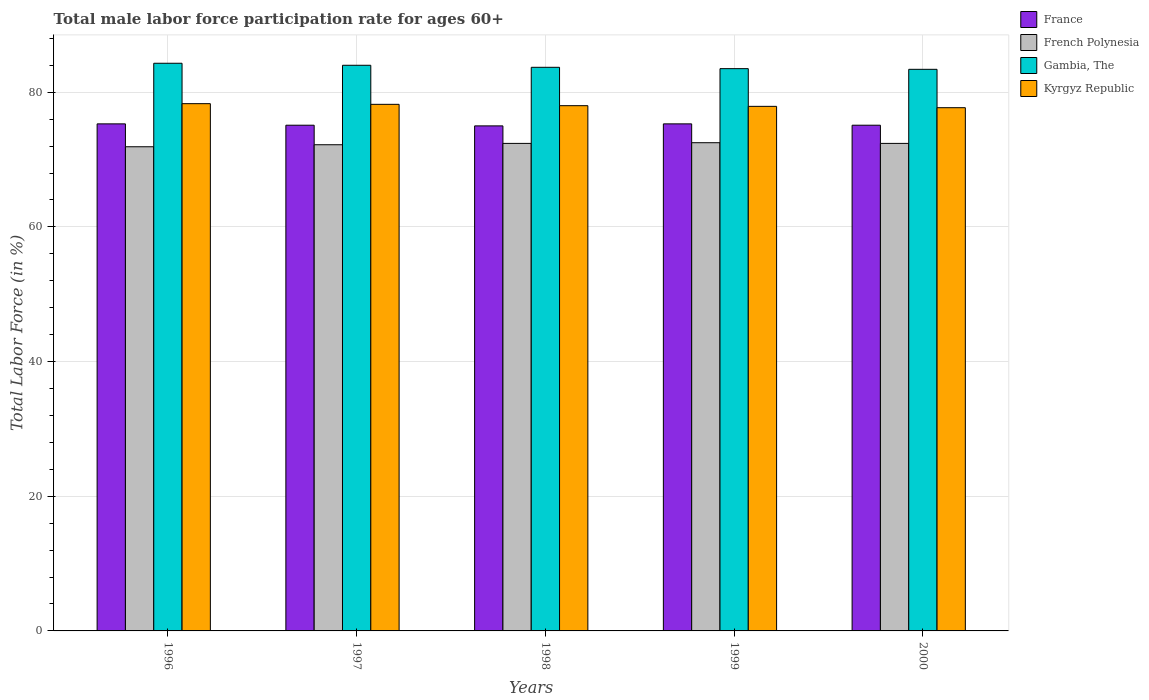How many different coloured bars are there?
Make the answer very short. 4. Are the number of bars on each tick of the X-axis equal?
Make the answer very short. Yes. Across all years, what is the maximum male labor force participation rate in Kyrgyz Republic?
Give a very brief answer. 78.3. In which year was the male labor force participation rate in French Polynesia maximum?
Provide a succinct answer. 1999. In which year was the male labor force participation rate in Kyrgyz Republic minimum?
Offer a very short reply. 2000. What is the total male labor force participation rate in French Polynesia in the graph?
Your response must be concise. 361.4. What is the difference between the male labor force participation rate in Gambia, The in 1997 and that in 2000?
Provide a short and direct response. 0.6. What is the difference between the male labor force participation rate in French Polynesia in 2000 and the male labor force participation rate in Gambia, The in 1997?
Give a very brief answer. -11.6. What is the average male labor force participation rate in French Polynesia per year?
Provide a succinct answer. 72.28. In the year 1998, what is the difference between the male labor force participation rate in Gambia, The and male labor force participation rate in Kyrgyz Republic?
Your response must be concise. 5.7. What is the ratio of the male labor force participation rate in France in 1997 to that in 1999?
Ensure brevity in your answer.  1. Is the difference between the male labor force participation rate in Gambia, The in 1997 and 1999 greater than the difference between the male labor force participation rate in Kyrgyz Republic in 1997 and 1999?
Provide a short and direct response. Yes. What is the difference between the highest and the second highest male labor force participation rate in France?
Provide a short and direct response. 0. What is the difference between the highest and the lowest male labor force participation rate in Kyrgyz Republic?
Offer a terse response. 0.6. Is the sum of the male labor force participation rate in Kyrgyz Republic in 1998 and 2000 greater than the maximum male labor force participation rate in French Polynesia across all years?
Your answer should be compact. Yes. Is it the case that in every year, the sum of the male labor force participation rate in French Polynesia and male labor force participation rate in Kyrgyz Republic is greater than the sum of male labor force participation rate in France and male labor force participation rate in Gambia, The?
Provide a succinct answer. No. What does the 3rd bar from the left in 1998 represents?
Your answer should be compact. Gambia, The. What does the 2nd bar from the right in 1997 represents?
Keep it short and to the point. Gambia, The. How many bars are there?
Your answer should be very brief. 20. Are all the bars in the graph horizontal?
Offer a terse response. No. What is the difference between two consecutive major ticks on the Y-axis?
Your response must be concise. 20. How are the legend labels stacked?
Provide a short and direct response. Vertical. What is the title of the graph?
Make the answer very short. Total male labor force participation rate for ages 60+. Does "Bahrain" appear as one of the legend labels in the graph?
Keep it short and to the point. No. What is the label or title of the X-axis?
Keep it short and to the point. Years. What is the Total Labor Force (in %) in France in 1996?
Offer a very short reply. 75.3. What is the Total Labor Force (in %) of French Polynesia in 1996?
Offer a very short reply. 71.9. What is the Total Labor Force (in %) of Gambia, The in 1996?
Your answer should be very brief. 84.3. What is the Total Labor Force (in %) in Kyrgyz Republic in 1996?
Offer a terse response. 78.3. What is the Total Labor Force (in %) of France in 1997?
Provide a succinct answer. 75.1. What is the Total Labor Force (in %) of French Polynesia in 1997?
Provide a succinct answer. 72.2. What is the Total Labor Force (in %) in Kyrgyz Republic in 1997?
Your answer should be compact. 78.2. What is the Total Labor Force (in %) in France in 1998?
Keep it short and to the point. 75. What is the Total Labor Force (in %) of French Polynesia in 1998?
Your response must be concise. 72.4. What is the Total Labor Force (in %) in Gambia, The in 1998?
Your answer should be compact. 83.7. What is the Total Labor Force (in %) in Kyrgyz Republic in 1998?
Provide a short and direct response. 78. What is the Total Labor Force (in %) of France in 1999?
Provide a short and direct response. 75.3. What is the Total Labor Force (in %) of French Polynesia in 1999?
Provide a short and direct response. 72.5. What is the Total Labor Force (in %) of Gambia, The in 1999?
Give a very brief answer. 83.5. What is the Total Labor Force (in %) in Kyrgyz Republic in 1999?
Offer a very short reply. 77.9. What is the Total Labor Force (in %) of France in 2000?
Provide a short and direct response. 75.1. What is the Total Labor Force (in %) of French Polynesia in 2000?
Ensure brevity in your answer.  72.4. What is the Total Labor Force (in %) in Gambia, The in 2000?
Offer a very short reply. 83.4. What is the Total Labor Force (in %) in Kyrgyz Republic in 2000?
Provide a short and direct response. 77.7. Across all years, what is the maximum Total Labor Force (in %) in France?
Keep it short and to the point. 75.3. Across all years, what is the maximum Total Labor Force (in %) in French Polynesia?
Your answer should be compact. 72.5. Across all years, what is the maximum Total Labor Force (in %) of Gambia, The?
Provide a succinct answer. 84.3. Across all years, what is the maximum Total Labor Force (in %) of Kyrgyz Republic?
Your answer should be compact. 78.3. Across all years, what is the minimum Total Labor Force (in %) in France?
Give a very brief answer. 75. Across all years, what is the minimum Total Labor Force (in %) of French Polynesia?
Offer a very short reply. 71.9. Across all years, what is the minimum Total Labor Force (in %) in Gambia, The?
Your answer should be very brief. 83.4. Across all years, what is the minimum Total Labor Force (in %) of Kyrgyz Republic?
Offer a terse response. 77.7. What is the total Total Labor Force (in %) in France in the graph?
Make the answer very short. 375.8. What is the total Total Labor Force (in %) in French Polynesia in the graph?
Your answer should be very brief. 361.4. What is the total Total Labor Force (in %) in Gambia, The in the graph?
Provide a succinct answer. 418.9. What is the total Total Labor Force (in %) in Kyrgyz Republic in the graph?
Provide a succinct answer. 390.1. What is the difference between the Total Labor Force (in %) in France in 1996 and that in 1997?
Offer a terse response. 0.2. What is the difference between the Total Labor Force (in %) in French Polynesia in 1996 and that in 1998?
Your answer should be compact. -0.5. What is the difference between the Total Labor Force (in %) in French Polynesia in 1996 and that in 1999?
Keep it short and to the point. -0.6. What is the difference between the Total Labor Force (in %) in Gambia, The in 1996 and that in 1999?
Offer a terse response. 0.8. What is the difference between the Total Labor Force (in %) of Kyrgyz Republic in 1996 and that in 1999?
Your response must be concise. 0.4. What is the difference between the Total Labor Force (in %) in French Polynesia in 1997 and that in 1999?
Offer a terse response. -0.3. What is the difference between the Total Labor Force (in %) of French Polynesia in 1997 and that in 2000?
Keep it short and to the point. -0.2. What is the difference between the Total Labor Force (in %) of French Polynesia in 1998 and that in 1999?
Ensure brevity in your answer.  -0.1. What is the difference between the Total Labor Force (in %) in Gambia, The in 1998 and that in 1999?
Make the answer very short. 0.2. What is the difference between the Total Labor Force (in %) in Kyrgyz Republic in 1998 and that in 1999?
Your response must be concise. 0.1. What is the difference between the Total Labor Force (in %) in France in 1998 and that in 2000?
Your answer should be very brief. -0.1. What is the difference between the Total Labor Force (in %) of Gambia, The in 1998 and that in 2000?
Offer a very short reply. 0.3. What is the difference between the Total Labor Force (in %) of Kyrgyz Republic in 1998 and that in 2000?
Provide a short and direct response. 0.3. What is the difference between the Total Labor Force (in %) in France in 1999 and that in 2000?
Ensure brevity in your answer.  0.2. What is the difference between the Total Labor Force (in %) of French Polynesia in 1999 and that in 2000?
Your answer should be very brief. 0.1. What is the difference between the Total Labor Force (in %) in France in 1996 and the Total Labor Force (in %) in Gambia, The in 1997?
Keep it short and to the point. -8.7. What is the difference between the Total Labor Force (in %) of French Polynesia in 1996 and the Total Labor Force (in %) of Gambia, The in 1997?
Offer a very short reply. -12.1. What is the difference between the Total Labor Force (in %) of French Polynesia in 1996 and the Total Labor Force (in %) of Kyrgyz Republic in 1997?
Provide a succinct answer. -6.3. What is the difference between the Total Labor Force (in %) of France in 1996 and the Total Labor Force (in %) of Gambia, The in 1998?
Your answer should be compact. -8.4. What is the difference between the Total Labor Force (in %) in France in 1996 and the Total Labor Force (in %) in Kyrgyz Republic in 1998?
Your response must be concise. -2.7. What is the difference between the Total Labor Force (in %) in Gambia, The in 1996 and the Total Labor Force (in %) in Kyrgyz Republic in 1998?
Offer a terse response. 6.3. What is the difference between the Total Labor Force (in %) in France in 1996 and the Total Labor Force (in %) in Kyrgyz Republic in 1999?
Make the answer very short. -2.6. What is the difference between the Total Labor Force (in %) in French Polynesia in 1996 and the Total Labor Force (in %) in Gambia, The in 2000?
Your response must be concise. -11.5. What is the difference between the Total Labor Force (in %) in French Polynesia in 1996 and the Total Labor Force (in %) in Kyrgyz Republic in 2000?
Your answer should be compact. -5.8. What is the difference between the Total Labor Force (in %) in France in 1997 and the Total Labor Force (in %) in French Polynesia in 1998?
Offer a very short reply. 2.7. What is the difference between the Total Labor Force (in %) in French Polynesia in 1997 and the Total Labor Force (in %) in Kyrgyz Republic in 1998?
Give a very brief answer. -5.8. What is the difference between the Total Labor Force (in %) of Gambia, The in 1997 and the Total Labor Force (in %) of Kyrgyz Republic in 1998?
Provide a succinct answer. 6. What is the difference between the Total Labor Force (in %) in France in 1997 and the Total Labor Force (in %) in French Polynesia in 1999?
Provide a succinct answer. 2.6. What is the difference between the Total Labor Force (in %) of France in 1997 and the Total Labor Force (in %) of Gambia, The in 1999?
Provide a short and direct response. -8.4. What is the difference between the Total Labor Force (in %) in France in 1997 and the Total Labor Force (in %) in Kyrgyz Republic in 1999?
Your answer should be compact. -2.8. What is the difference between the Total Labor Force (in %) in France in 1997 and the Total Labor Force (in %) in Gambia, The in 2000?
Keep it short and to the point. -8.3. What is the difference between the Total Labor Force (in %) in France in 1997 and the Total Labor Force (in %) in Kyrgyz Republic in 2000?
Your answer should be very brief. -2.6. What is the difference between the Total Labor Force (in %) of French Polynesia in 1997 and the Total Labor Force (in %) of Gambia, The in 2000?
Offer a very short reply. -11.2. What is the difference between the Total Labor Force (in %) of French Polynesia in 1997 and the Total Labor Force (in %) of Kyrgyz Republic in 2000?
Make the answer very short. -5.5. What is the difference between the Total Labor Force (in %) of Gambia, The in 1997 and the Total Labor Force (in %) of Kyrgyz Republic in 2000?
Offer a very short reply. 6.3. What is the difference between the Total Labor Force (in %) of France in 1998 and the Total Labor Force (in %) of Gambia, The in 1999?
Your answer should be compact. -8.5. What is the difference between the Total Labor Force (in %) in France in 1998 and the Total Labor Force (in %) in Kyrgyz Republic in 1999?
Provide a succinct answer. -2.9. What is the difference between the Total Labor Force (in %) of French Polynesia in 1998 and the Total Labor Force (in %) of Gambia, The in 1999?
Keep it short and to the point. -11.1. What is the difference between the Total Labor Force (in %) of French Polynesia in 1998 and the Total Labor Force (in %) of Kyrgyz Republic in 1999?
Ensure brevity in your answer.  -5.5. What is the difference between the Total Labor Force (in %) in Gambia, The in 1998 and the Total Labor Force (in %) in Kyrgyz Republic in 1999?
Offer a very short reply. 5.8. What is the difference between the Total Labor Force (in %) in France in 1998 and the Total Labor Force (in %) in French Polynesia in 2000?
Your answer should be very brief. 2.6. What is the difference between the Total Labor Force (in %) of France in 1998 and the Total Labor Force (in %) of Kyrgyz Republic in 2000?
Your answer should be very brief. -2.7. What is the difference between the Total Labor Force (in %) in French Polynesia in 1998 and the Total Labor Force (in %) in Kyrgyz Republic in 2000?
Provide a short and direct response. -5.3. What is the difference between the Total Labor Force (in %) in France in 1999 and the Total Labor Force (in %) in French Polynesia in 2000?
Offer a very short reply. 2.9. What is the difference between the Total Labor Force (in %) of France in 1999 and the Total Labor Force (in %) of Gambia, The in 2000?
Your answer should be compact. -8.1. What is the difference between the Total Labor Force (in %) of France in 1999 and the Total Labor Force (in %) of Kyrgyz Republic in 2000?
Ensure brevity in your answer.  -2.4. What is the difference between the Total Labor Force (in %) in Gambia, The in 1999 and the Total Labor Force (in %) in Kyrgyz Republic in 2000?
Give a very brief answer. 5.8. What is the average Total Labor Force (in %) of France per year?
Your response must be concise. 75.16. What is the average Total Labor Force (in %) of French Polynesia per year?
Offer a very short reply. 72.28. What is the average Total Labor Force (in %) of Gambia, The per year?
Ensure brevity in your answer.  83.78. What is the average Total Labor Force (in %) of Kyrgyz Republic per year?
Ensure brevity in your answer.  78.02. In the year 1996, what is the difference between the Total Labor Force (in %) of Gambia, The and Total Labor Force (in %) of Kyrgyz Republic?
Provide a succinct answer. 6. In the year 1997, what is the difference between the Total Labor Force (in %) in France and Total Labor Force (in %) in French Polynesia?
Make the answer very short. 2.9. In the year 1997, what is the difference between the Total Labor Force (in %) of France and Total Labor Force (in %) of Gambia, The?
Your answer should be very brief. -8.9. In the year 1997, what is the difference between the Total Labor Force (in %) in French Polynesia and Total Labor Force (in %) in Gambia, The?
Your answer should be compact. -11.8. In the year 1997, what is the difference between the Total Labor Force (in %) in French Polynesia and Total Labor Force (in %) in Kyrgyz Republic?
Ensure brevity in your answer.  -6. In the year 1998, what is the difference between the Total Labor Force (in %) in French Polynesia and Total Labor Force (in %) in Gambia, The?
Give a very brief answer. -11.3. In the year 1998, what is the difference between the Total Labor Force (in %) in French Polynesia and Total Labor Force (in %) in Kyrgyz Republic?
Ensure brevity in your answer.  -5.6. In the year 1998, what is the difference between the Total Labor Force (in %) of Gambia, The and Total Labor Force (in %) of Kyrgyz Republic?
Give a very brief answer. 5.7. In the year 1999, what is the difference between the Total Labor Force (in %) in France and Total Labor Force (in %) in French Polynesia?
Offer a terse response. 2.8. In the year 1999, what is the difference between the Total Labor Force (in %) in France and Total Labor Force (in %) in Kyrgyz Republic?
Give a very brief answer. -2.6. In the year 1999, what is the difference between the Total Labor Force (in %) in French Polynesia and Total Labor Force (in %) in Kyrgyz Republic?
Make the answer very short. -5.4. In the year 2000, what is the difference between the Total Labor Force (in %) of France and Total Labor Force (in %) of Kyrgyz Republic?
Your answer should be very brief. -2.6. In the year 2000, what is the difference between the Total Labor Force (in %) in French Polynesia and Total Labor Force (in %) in Kyrgyz Republic?
Your response must be concise. -5.3. In the year 2000, what is the difference between the Total Labor Force (in %) in Gambia, The and Total Labor Force (in %) in Kyrgyz Republic?
Your answer should be compact. 5.7. What is the ratio of the Total Labor Force (in %) of France in 1996 to that in 1997?
Your response must be concise. 1. What is the ratio of the Total Labor Force (in %) of Gambia, The in 1996 to that in 1997?
Offer a very short reply. 1. What is the ratio of the Total Labor Force (in %) in Kyrgyz Republic in 1996 to that in 1997?
Ensure brevity in your answer.  1. What is the ratio of the Total Labor Force (in %) of French Polynesia in 1996 to that in 1998?
Make the answer very short. 0.99. What is the ratio of the Total Labor Force (in %) of Kyrgyz Republic in 1996 to that in 1998?
Offer a terse response. 1. What is the ratio of the Total Labor Force (in %) of Gambia, The in 1996 to that in 1999?
Give a very brief answer. 1.01. What is the ratio of the Total Labor Force (in %) in Kyrgyz Republic in 1996 to that in 1999?
Your response must be concise. 1.01. What is the ratio of the Total Labor Force (in %) in France in 1996 to that in 2000?
Offer a terse response. 1. What is the ratio of the Total Labor Force (in %) in Gambia, The in 1996 to that in 2000?
Your answer should be very brief. 1.01. What is the ratio of the Total Labor Force (in %) in Kyrgyz Republic in 1996 to that in 2000?
Offer a very short reply. 1.01. What is the ratio of the Total Labor Force (in %) in France in 1997 to that in 1998?
Offer a terse response. 1. What is the ratio of the Total Labor Force (in %) of French Polynesia in 1997 to that in 1998?
Ensure brevity in your answer.  1. What is the ratio of the Total Labor Force (in %) of Gambia, The in 1997 to that in 1998?
Ensure brevity in your answer.  1. What is the ratio of the Total Labor Force (in %) in Kyrgyz Republic in 1997 to that in 1998?
Your answer should be compact. 1. What is the ratio of the Total Labor Force (in %) of French Polynesia in 1997 to that in 1999?
Your response must be concise. 1. What is the ratio of the Total Labor Force (in %) in Gambia, The in 1997 to that in 1999?
Offer a terse response. 1.01. What is the ratio of the Total Labor Force (in %) of Kyrgyz Republic in 1997 to that in 1999?
Ensure brevity in your answer.  1. What is the ratio of the Total Labor Force (in %) in France in 1997 to that in 2000?
Your answer should be very brief. 1. What is the ratio of the Total Labor Force (in %) of French Polynesia in 1997 to that in 2000?
Your answer should be very brief. 1. What is the ratio of the Total Labor Force (in %) of Kyrgyz Republic in 1997 to that in 2000?
Your answer should be very brief. 1.01. What is the ratio of the Total Labor Force (in %) of French Polynesia in 1998 to that in 1999?
Your response must be concise. 1. What is the ratio of the Total Labor Force (in %) of Gambia, The in 1998 to that in 1999?
Offer a very short reply. 1. What is the ratio of the Total Labor Force (in %) in Kyrgyz Republic in 1998 to that in 2000?
Offer a very short reply. 1. What is the ratio of the Total Labor Force (in %) in Gambia, The in 1999 to that in 2000?
Your answer should be very brief. 1. What is the difference between the highest and the second highest Total Labor Force (in %) in France?
Provide a succinct answer. 0. What is the difference between the highest and the second highest Total Labor Force (in %) in Gambia, The?
Provide a succinct answer. 0.3. What is the difference between the highest and the lowest Total Labor Force (in %) of French Polynesia?
Your response must be concise. 0.6. What is the difference between the highest and the lowest Total Labor Force (in %) of Kyrgyz Republic?
Your answer should be very brief. 0.6. 